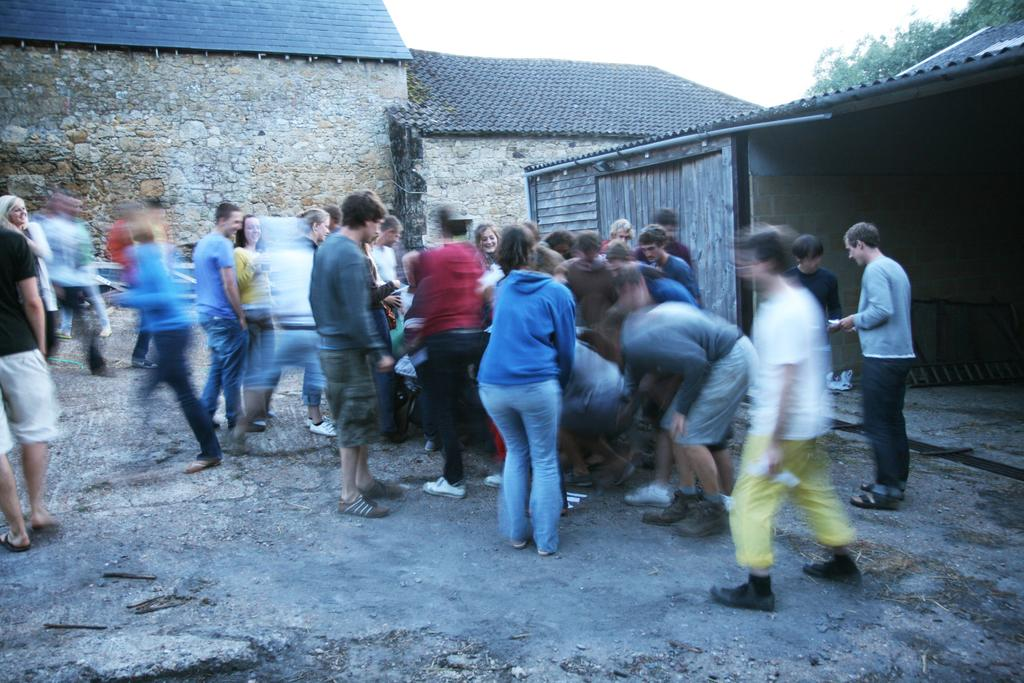What is happening on the road in the image? There is a crowd on the road in the image. What can be seen in the background of the image? There is a shed, houses, and trees in the background of the image. What is visible at the top of the image? The sky is visible at the top of the image. When was the image taken? The image was taken during the day. What type of berry is being picked in the image? There is no berry or berry-picking activity present in the image. Can you see any caves in the image? There are no caves visible in the image; it features a crowd on the road, a shed, houses, trees, and the sky. 